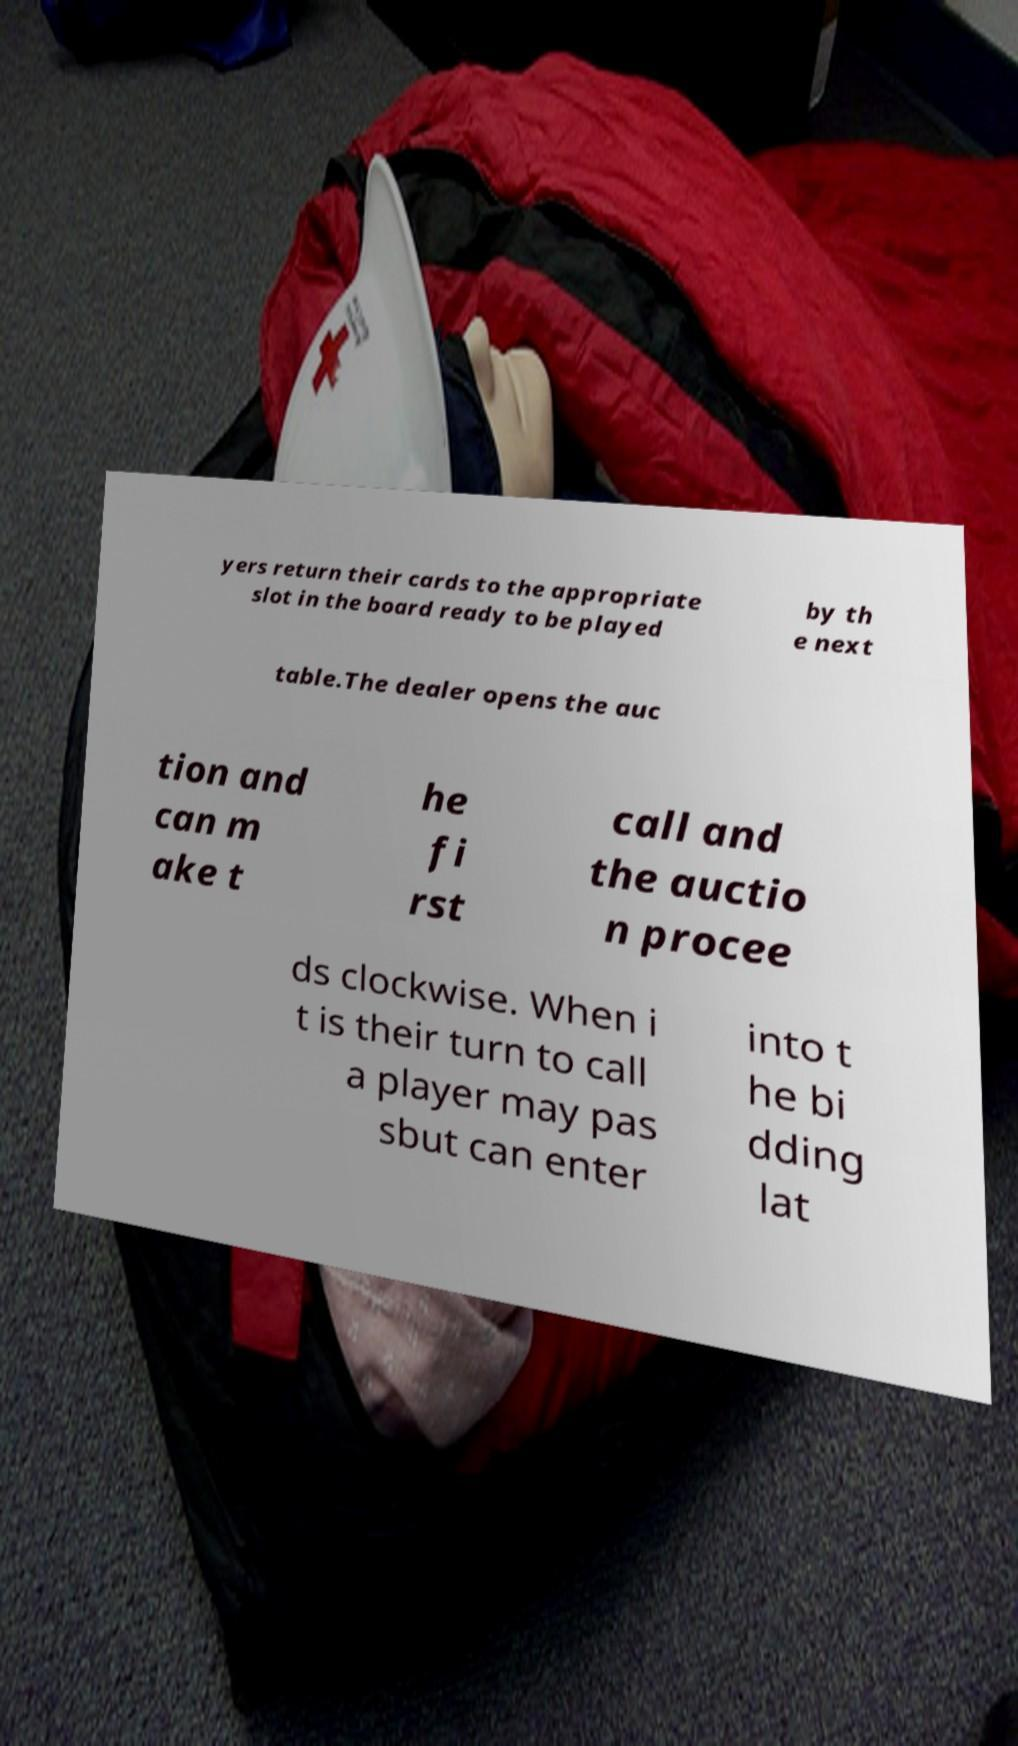I need the written content from this picture converted into text. Can you do that? yers return their cards to the appropriate slot in the board ready to be played by th e next table.The dealer opens the auc tion and can m ake t he fi rst call and the auctio n procee ds clockwise. When i t is their turn to call a player may pas sbut can enter into t he bi dding lat 